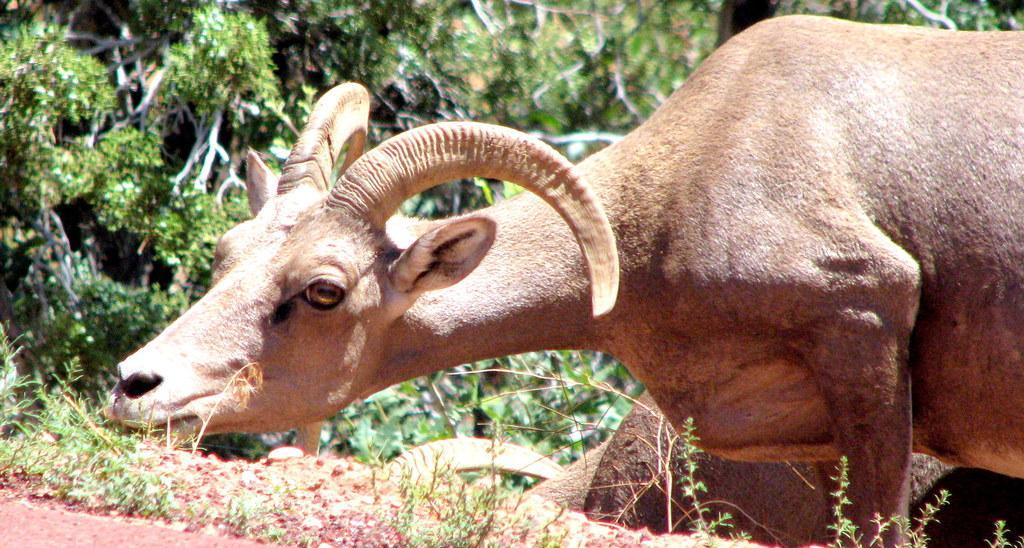Could you give a brief overview of what you see in this image? In this image we can see many trees and plants. There are few animals in the image. 